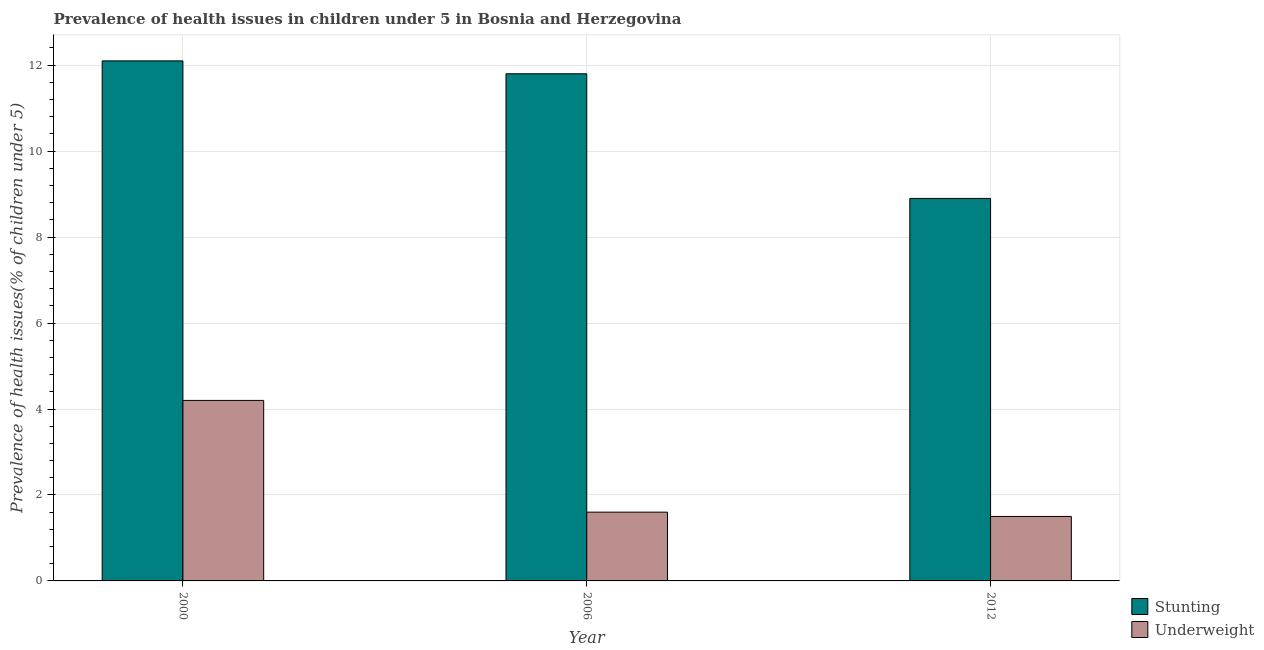How many groups of bars are there?
Your answer should be compact. 3. Are the number of bars per tick equal to the number of legend labels?
Offer a very short reply. Yes. Are the number of bars on each tick of the X-axis equal?
Keep it short and to the point. Yes. How many bars are there on the 3rd tick from the right?
Keep it short and to the point. 2. What is the label of the 3rd group of bars from the left?
Offer a terse response. 2012. What is the percentage of stunted children in 2012?
Your answer should be compact. 8.9. Across all years, what is the maximum percentage of stunted children?
Provide a short and direct response. 12.1. Across all years, what is the minimum percentage of stunted children?
Ensure brevity in your answer.  8.9. In which year was the percentage of underweight children maximum?
Your answer should be very brief. 2000. In which year was the percentage of underweight children minimum?
Give a very brief answer. 2012. What is the total percentage of underweight children in the graph?
Give a very brief answer. 7.3. What is the difference between the percentage of stunted children in 2000 and that in 2012?
Provide a short and direct response. 3.2. What is the difference between the percentage of underweight children in 2012 and the percentage of stunted children in 2000?
Your response must be concise. -2.7. What is the average percentage of underweight children per year?
Your response must be concise. 2.43. In the year 2006, what is the difference between the percentage of underweight children and percentage of stunted children?
Your response must be concise. 0. In how many years, is the percentage of stunted children greater than 3.2 %?
Your answer should be compact. 3. What is the ratio of the percentage of underweight children in 2000 to that in 2012?
Provide a short and direct response. 2.8. Is the difference between the percentage of stunted children in 2000 and 2006 greater than the difference between the percentage of underweight children in 2000 and 2006?
Provide a succinct answer. No. What is the difference between the highest and the second highest percentage of stunted children?
Your answer should be very brief. 0.3. What is the difference between the highest and the lowest percentage of stunted children?
Give a very brief answer. 3.2. What does the 2nd bar from the left in 2000 represents?
Your answer should be very brief. Underweight. What does the 1st bar from the right in 2006 represents?
Provide a short and direct response. Underweight. How many bars are there?
Make the answer very short. 6. Are all the bars in the graph horizontal?
Keep it short and to the point. No. What is the difference between two consecutive major ticks on the Y-axis?
Offer a very short reply. 2. Are the values on the major ticks of Y-axis written in scientific E-notation?
Offer a very short reply. No. Does the graph contain any zero values?
Ensure brevity in your answer.  No. How many legend labels are there?
Keep it short and to the point. 2. What is the title of the graph?
Provide a succinct answer. Prevalence of health issues in children under 5 in Bosnia and Herzegovina. Does "National Tourists" appear as one of the legend labels in the graph?
Keep it short and to the point. No. What is the label or title of the X-axis?
Make the answer very short. Year. What is the label or title of the Y-axis?
Your answer should be compact. Prevalence of health issues(% of children under 5). What is the Prevalence of health issues(% of children under 5) of Stunting in 2000?
Your answer should be very brief. 12.1. What is the Prevalence of health issues(% of children under 5) in Underweight in 2000?
Provide a short and direct response. 4.2. What is the Prevalence of health issues(% of children under 5) in Stunting in 2006?
Offer a terse response. 11.8. What is the Prevalence of health issues(% of children under 5) in Underweight in 2006?
Offer a terse response. 1.6. What is the Prevalence of health issues(% of children under 5) of Stunting in 2012?
Your answer should be compact. 8.9. What is the Prevalence of health issues(% of children under 5) in Underweight in 2012?
Offer a very short reply. 1.5. Across all years, what is the maximum Prevalence of health issues(% of children under 5) of Stunting?
Give a very brief answer. 12.1. Across all years, what is the maximum Prevalence of health issues(% of children under 5) in Underweight?
Offer a very short reply. 4.2. Across all years, what is the minimum Prevalence of health issues(% of children under 5) in Stunting?
Your answer should be very brief. 8.9. What is the total Prevalence of health issues(% of children under 5) of Stunting in the graph?
Provide a succinct answer. 32.8. What is the total Prevalence of health issues(% of children under 5) of Underweight in the graph?
Provide a succinct answer. 7.3. What is the difference between the Prevalence of health issues(% of children under 5) of Underweight in 2000 and that in 2006?
Offer a very short reply. 2.6. What is the difference between the Prevalence of health issues(% of children under 5) in Stunting in 2000 and that in 2012?
Provide a succinct answer. 3.2. What is the difference between the Prevalence of health issues(% of children under 5) in Stunting in 2006 and that in 2012?
Ensure brevity in your answer.  2.9. What is the difference between the Prevalence of health issues(% of children under 5) of Stunting in 2000 and the Prevalence of health issues(% of children under 5) of Underweight in 2006?
Offer a very short reply. 10.5. What is the difference between the Prevalence of health issues(% of children under 5) of Stunting in 2000 and the Prevalence of health issues(% of children under 5) of Underweight in 2012?
Offer a terse response. 10.6. What is the average Prevalence of health issues(% of children under 5) in Stunting per year?
Make the answer very short. 10.93. What is the average Prevalence of health issues(% of children under 5) of Underweight per year?
Offer a very short reply. 2.43. In the year 2000, what is the difference between the Prevalence of health issues(% of children under 5) of Stunting and Prevalence of health issues(% of children under 5) of Underweight?
Ensure brevity in your answer.  7.9. In the year 2006, what is the difference between the Prevalence of health issues(% of children under 5) in Stunting and Prevalence of health issues(% of children under 5) in Underweight?
Your answer should be very brief. 10.2. In the year 2012, what is the difference between the Prevalence of health issues(% of children under 5) of Stunting and Prevalence of health issues(% of children under 5) of Underweight?
Provide a succinct answer. 7.4. What is the ratio of the Prevalence of health issues(% of children under 5) in Stunting in 2000 to that in 2006?
Keep it short and to the point. 1.03. What is the ratio of the Prevalence of health issues(% of children under 5) of Underweight in 2000 to that in 2006?
Your answer should be very brief. 2.62. What is the ratio of the Prevalence of health issues(% of children under 5) in Stunting in 2000 to that in 2012?
Provide a short and direct response. 1.36. What is the ratio of the Prevalence of health issues(% of children under 5) of Stunting in 2006 to that in 2012?
Offer a very short reply. 1.33. What is the ratio of the Prevalence of health issues(% of children under 5) in Underweight in 2006 to that in 2012?
Provide a succinct answer. 1.07. What is the difference between the highest and the lowest Prevalence of health issues(% of children under 5) in Underweight?
Offer a terse response. 2.7. 